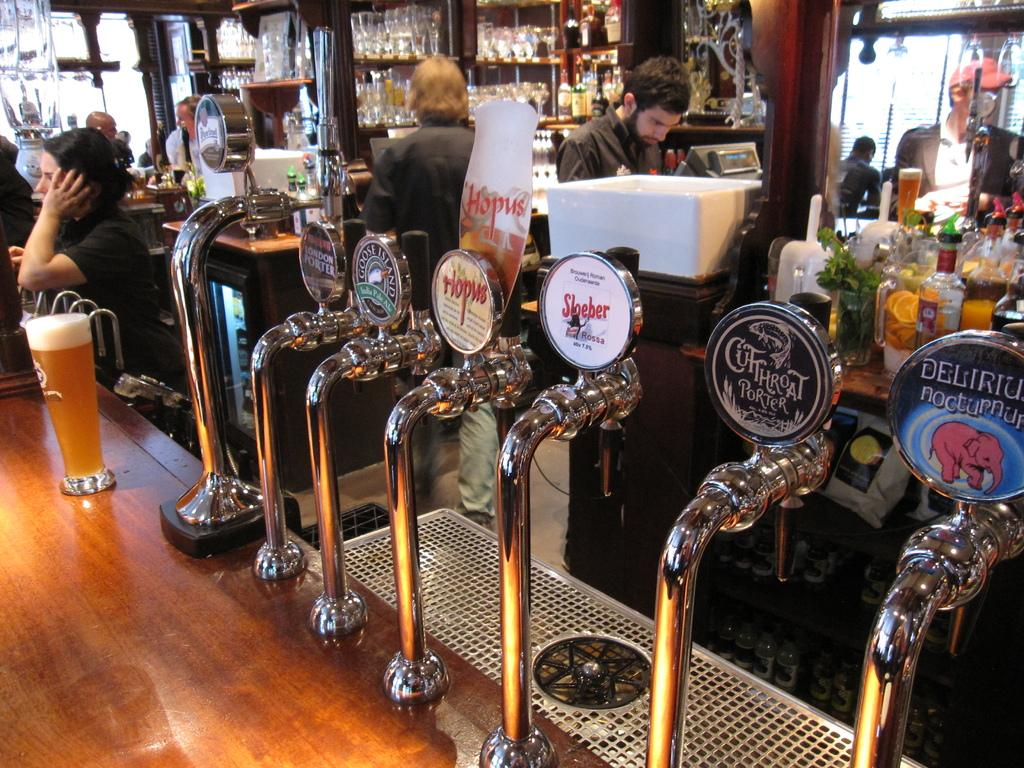Provide a one-sentence caption for the provided image. Beer hands in a bar with Sloeber beer in the middle. 